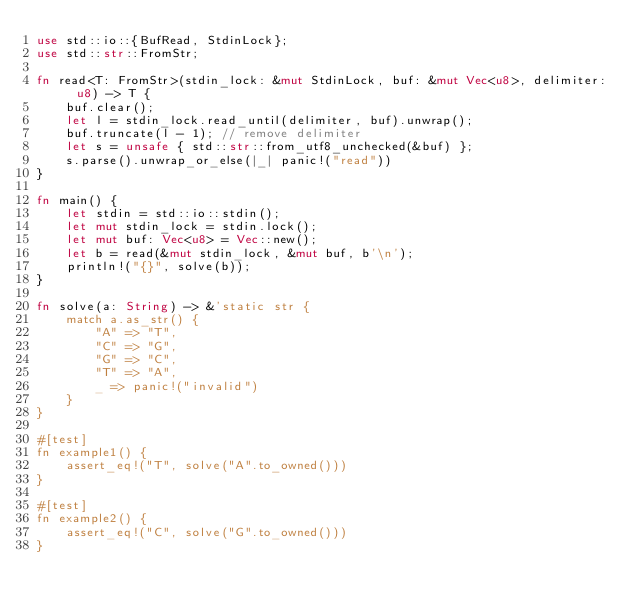<code> <loc_0><loc_0><loc_500><loc_500><_Rust_>use std::io::{BufRead, StdinLock};
use std::str::FromStr;

fn read<T: FromStr>(stdin_lock: &mut StdinLock, buf: &mut Vec<u8>, delimiter: u8) -> T {
    buf.clear();
    let l = stdin_lock.read_until(delimiter, buf).unwrap();
    buf.truncate(l - 1); // remove delimiter
    let s = unsafe { std::str::from_utf8_unchecked(&buf) };
    s.parse().unwrap_or_else(|_| panic!("read"))
}

fn main() {
    let stdin = std::io::stdin();
    let mut stdin_lock = stdin.lock();
    let mut buf: Vec<u8> = Vec::new();
    let b = read(&mut stdin_lock, &mut buf, b'\n');
    println!("{}", solve(b));
}

fn solve(a: String) -> &'static str {
    match a.as_str() {
        "A" => "T",
        "C" => "G",
        "G" => "C",
        "T" => "A",
        _ => panic!("invalid")
    }
}

#[test]
fn example1() {
    assert_eq!("T", solve("A".to_owned()))
}

#[test]
fn example2() {
    assert_eq!("C", solve("G".to_owned()))
}
</code> 